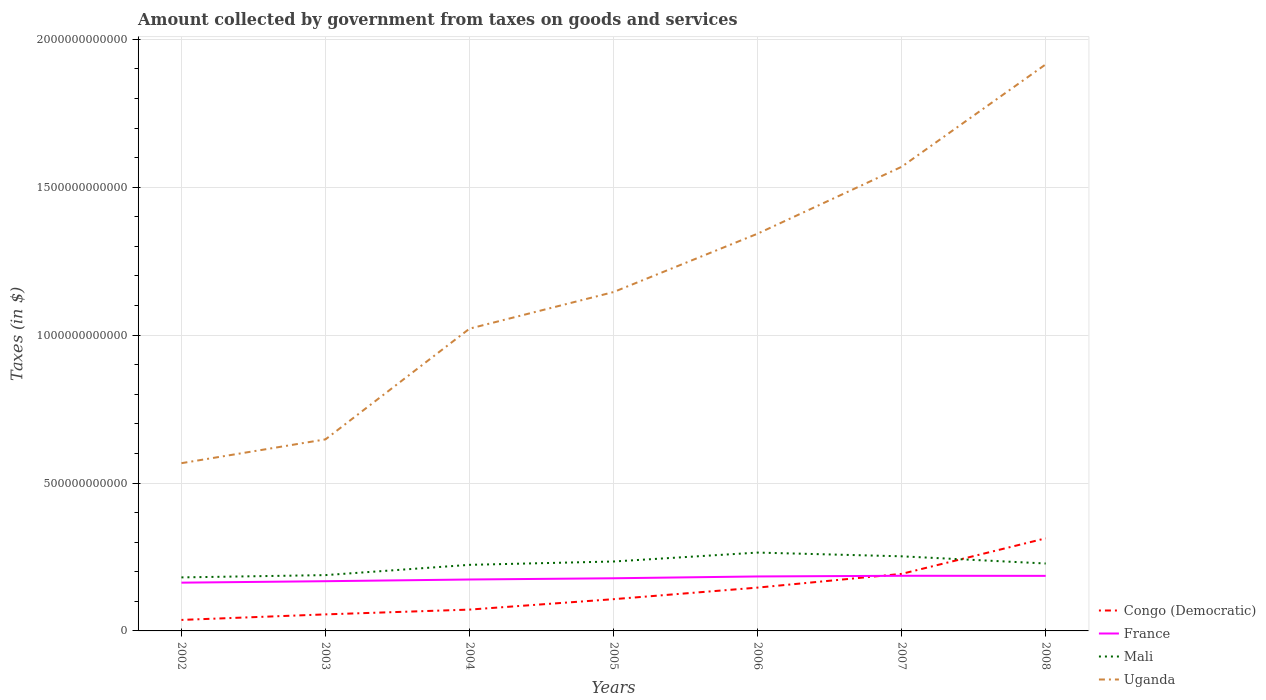Is the number of lines equal to the number of legend labels?
Provide a succinct answer. Yes. Across all years, what is the maximum amount collected by government from taxes on goods and services in Uganda?
Your answer should be very brief. 5.67e+11. What is the total amount collected by government from taxes on goods and services in Congo (Democratic) in the graph?
Your answer should be very brief. -5.14e+1. What is the difference between the highest and the second highest amount collected by government from taxes on goods and services in Congo (Democratic)?
Your answer should be compact. 2.76e+11. What is the difference between the highest and the lowest amount collected by government from taxes on goods and services in Congo (Democratic)?
Keep it short and to the point. 3. How many lines are there?
Provide a short and direct response. 4. How many years are there in the graph?
Your response must be concise. 7. What is the difference between two consecutive major ticks on the Y-axis?
Keep it short and to the point. 5.00e+11. Are the values on the major ticks of Y-axis written in scientific E-notation?
Your answer should be very brief. No. Does the graph contain grids?
Give a very brief answer. Yes. Where does the legend appear in the graph?
Make the answer very short. Bottom right. How many legend labels are there?
Ensure brevity in your answer.  4. What is the title of the graph?
Your answer should be very brief. Amount collected by government from taxes on goods and services. What is the label or title of the X-axis?
Your response must be concise. Years. What is the label or title of the Y-axis?
Your answer should be compact. Taxes (in $). What is the Taxes (in $) of Congo (Democratic) in 2002?
Your answer should be compact. 3.72e+1. What is the Taxes (in $) in France in 2002?
Offer a very short reply. 1.63e+11. What is the Taxes (in $) of Mali in 2002?
Your answer should be compact. 1.81e+11. What is the Taxes (in $) in Uganda in 2002?
Offer a terse response. 5.67e+11. What is the Taxes (in $) of Congo (Democratic) in 2003?
Your answer should be compact. 5.59e+1. What is the Taxes (in $) of France in 2003?
Your answer should be very brief. 1.68e+11. What is the Taxes (in $) of Mali in 2003?
Your answer should be compact. 1.89e+11. What is the Taxes (in $) of Uganda in 2003?
Give a very brief answer. 6.48e+11. What is the Taxes (in $) in Congo (Democratic) in 2004?
Offer a terse response. 7.21e+1. What is the Taxes (in $) in France in 2004?
Provide a short and direct response. 1.74e+11. What is the Taxes (in $) in Mali in 2004?
Your answer should be very brief. 2.23e+11. What is the Taxes (in $) of Uganda in 2004?
Keep it short and to the point. 1.02e+12. What is the Taxes (in $) of Congo (Democratic) in 2005?
Your answer should be compact. 1.07e+11. What is the Taxes (in $) of France in 2005?
Offer a very short reply. 1.78e+11. What is the Taxes (in $) of Mali in 2005?
Your answer should be very brief. 2.35e+11. What is the Taxes (in $) in Uganda in 2005?
Offer a terse response. 1.15e+12. What is the Taxes (in $) in Congo (Democratic) in 2006?
Your response must be concise. 1.46e+11. What is the Taxes (in $) in France in 2006?
Your answer should be very brief. 1.84e+11. What is the Taxes (in $) of Mali in 2006?
Offer a terse response. 2.65e+11. What is the Taxes (in $) of Uganda in 2006?
Provide a short and direct response. 1.34e+12. What is the Taxes (in $) of Congo (Democratic) in 2007?
Offer a very short reply. 1.93e+11. What is the Taxes (in $) of France in 2007?
Offer a very short reply. 1.86e+11. What is the Taxes (in $) in Mali in 2007?
Keep it short and to the point. 2.52e+11. What is the Taxes (in $) in Uganda in 2007?
Provide a succinct answer. 1.57e+12. What is the Taxes (in $) in Congo (Democratic) in 2008?
Offer a very short reply. 3.13e+11. What is the Taxes (in $) of France in 2008?
Give a very brief answer. 1.86e+11. What is the Taxes (in $) of Mali in 2008?
Provide a short and direct response. 2.28e+11. What is the Taxes (in $) in Uganda in 2008?
Provide a short and direct response. 1.92e+12. Across all years, what is the maximum Taxes (in $) in Congo (Democratic)?
Offer a terse response. 3.13e+11. Across all years, what is the maximum Taxes (in $) in France?
Offer a very short reply. 1.86e+11. Across all years, what is the maximum Taxes (in $) of Mali?
Offer a very short reply. 2.65e+11. Across all years, what is the maximum Taxes (in $) in Uganda?
Provide a succinct answer. 1.92e+12. Across all years, what is the minimum Taxes (in $) of Congo (Democratic)?
Your answer should be compact. 3.72e+1. Across all years, what is the minimum Taxes (in $) in France?
Your answer should be very brief. 1.63e+11. Across all years, what is the minimum Taxes (in $) of Mali?
Make the answer very short. 1.81e+11. Across all years, what is the minimum Taxes (in $) of Uganda?
Keep it short and to the point. 5.67e+11. What is the total Taxes (in $) in Congo (Democratic) in the graph?
Your response must be concise. 9.25e+11. What is the total Taxes (in $) of France in the graph?
Give a very brief answer. 1.24e+12. What is the total Taxes (in $) of Mali in the graph?
Your answer should be very brief. 1.57e+12. What is the total Taxes (in $) of Uganda in the graph?
Your answer should be compact. 8.21e+12. What is the difference between the Taxes (in $) in Congo (Democratic) in 2002 and that in 2003?
Your answer should be compact. -1.87e+1. What is the difference between the Taxes (in $) in France in 2002 and that in 2003?
Provide a short and direct response. -4.87e+09. What is the difference between the Taxes (in $) of Mali in 2002 and that in 2003?
Your answer should be compact. -7.72e+09. What is the difference between the Taxes (in $) of Uganda in 2002 and that in 2003?
Make the answer very short. -8.05e+1. What is the difference between the Taxes (in $) in Congo (Democratic) in 2002 and that in 2004?
Your answer should be very brief. -3.49e+1. What is the difference between the Taxes (in $) of France in 2002 and that in 2004?
Your response must be concise. -1.06e+1. What is the difference between the Taxes (in $) of Mali in 2002 and that in 2004?
Make the answer very short. -4.24e+1. What is the difference between the Taxes (in $) of Uganda in 2002 and that in 2004?
Offer a very short reply. -4.55e+11. What is the difference between the Taxes (in $) in Congo (Democratic) in 2002 and that in 2005?
Keep it short and to the point. -7.02e+1. What is the difference between the Taxes (in $) of France in 2002 and that in 2005?
Give a very brief answer. -1.48e+1. What is the difference between the Taxes (in $) in Mali in 2002 and that in 2005?
Your answer should be very brief. -5.37e+1. What is the difference between the Taxes (in $) of Uganda in 2002 and that in 2005?
Keep it short and to the point. -5.78e+11. What is the difference between the Taxes (in $) of Congo (Democratic) in 2002 and that in 2006?
Your answer should be compact. -1.09e+11. What is the difference between the Taxes (in $) of France in 2002 and that in 2006?
Keep it short and to the point. -2.09e+1. What is the difference between the Taxes (in $) in Mali in 2002 and that in 2006?
Keep it short and to the point. -8.39e+1. What is the difference between the Taxes (in $) of Uganda in 2002 and that in 2006?
Make the answer very short. -7.76e+11. What is the difference between the Taxes (in $) of Congo (Democratic) in 2002 and that in 2007?
Provide a short and direct response. -1.56e+11. What is the difference between the Taxes (in $) in France in 2002 and that in 2007?
Ensure brevity in your answer.  -2.32e+1. What is the difference between the Taxes (in $) of Mali in 2002 and that in 2007?
Make the answer very short. -7.13e+1. What is the difference between the Taxes (in $) in Uganda in 2002 and that in 2007?
Offer a very short reply. -1.00e+12. What is the difference between the Taxes (in $) of Congo (Democratic) in 2002 and that in 2008?
Keep it short and to the point. -2.76e+11. What is the difference between the Taxes (in $) in France in 2002 and that in 2008?
Provide a succinct answer. -2.29e+1. What is the difference between the Taxes (in $) of Mali in 2002 and that in 2008?
Offer a very short reply. -4.70e+1. What is the difference between the Taxes (in $) in Uganda in 2002 and that in 2008?
Keep it short and to the point. -1.35e+12. What is the difference between the Taxes (in $) in Congo (Democratic) in 2003 and that in 2004?
Your response must be concise. -1.62e+1. What is the difference between the Taxes (in $) in France in 2003 and that in 2004?
Offer a very short reply. -5.76e+09. What is the difference between the Taxes (in $) in Mali in 2003 and that in 2004?
Your answer should be very brief. -3.47e+1. What is the difference between the Taxes (in $) of Uganda in 2003 and that in 2004?
Your response must be concise. -3.74e+11. What is the difference between the Taxes (in $) of Congo (Democratic) in 2003 and that in 2005?
Your response must be concise. -5.14e+1. What is the difference between the Taxes (in $) in France in 2003 and that in 2005?
Provide a succinct answer. -9.95e+09. What is the difference between the Taxes (in $) of Mali in 2003 and that in 2005?
Offer a terse response. -4.60e+1. What is the difference between the Taxes (in $) of Uganda in 2003 and that in 2005?
Keep it short and to the point. -4.98e+11. What is the difference between the Taxes (in $) in Congo (Democratic) in 2003 and that in 2006?
Your response must be concise. -9.05e+1. What is the difference between the Taxes (in $) of France in 2003 and that in 2006?
Provide a short and direct response. -1.61e+1. What is the difference between the Taxes (in $) of Mali in 2003 and that in 2006?
Keep it short and to the point. -7.62e+1. What is the difference between the Taxes (in $) of Uganda in 2003 and that in 2006?
Provide a succinct answer. -6.95e+11. What is the difference between the Taxes (in $) of Congo (Democratic) in 2003 and that in 2007?
Offer a terse response. -1.37e+11. What is the difference between the Taxes (in $) in France in 2003 and that in 2007?
Provide a succinct answer. -1.84e+1. What is the difference between the Taxes (in $) in Mali in 2003 and that in 2007?
Offer a very short reply. -6.35e+1. What is the difference between the Taxes (in $) of Uganda in 2003 and that in 2007?
Your response must be concise. -9.21e+11. What is the difference between the Taxes (in $) in Congo (Democratic) in 2003 and that in 2008?
Your answer should be very brief. -2.57e+11. What is the difference between the Taxes (in $) in France in 2003 and that in 2008?
Offer a terse response. -1.81e+1. What is the difference between the Taxes (in $) in Mali in 2003 and that in 2008?
Ensure brevity in your answer.  -3.92e+1. What is the difference between the Taxes (in $) in Uganda in 2003 and that in 2008?
Your answer should be compact. -1.27e+12. What is the difference between the Taxes (in $) in Congo (Democratic) in 2004 and that in 2005?
Provide a succinct answer. -3.52e+1. What is the difference between the Taxes (in $) in France in 2004 and that in 2005?
Offer a very short reply. -4.18e+09. What is the difference between the Taxes (in $) of Mali in 2004 and that in 2005?
Your answer should be compact. -1.13e+1. What is the difference between the Taxes (in $) of Uganda in 2004 and that in 2005?
Your response must be concise. -1.24e+11. What is the difference between the Taxes (in $) in Congo (Democratic) in 2004 and that in 2006?
Give a very brief answer. -7.43e+1. What is the difference between the Taxes (in $) of France in 2004 and that in 2006?
Your response must be concise. -1.03e+1. What is the difference between the Taxes (in $) in Mali in 2004 and that in 2006?
Make the answer very short. -4.14e+1. What is the difference between the Taxes (in $) of Uganda in 2004 and that in 2006?
Give a very brief answer. -3.21e+11. What is the difference between the Taxes (in $) in Congo (Democratic) in 2004 and that in 2007?
Your response must be concise. -1.21e+11. What is the difference between the Taxes (in $) in France in 2004 and that in 2007?
Your answer should be compact. -1.26e+1. What is the difference between the Taxes (in $) of Mali in 2004 and that in 2007?
Offer a very short reply. -2.88e+1. What is the difference between the Taxes (in $) of Uganda in 2004 and that in 2007?
Your response must be concise. -5.47e+11. What is the difference between the Taxes (in $) in Congo (Democratic) in 2004 and that in 2008?
Give a very brief answer. -2.41e+11. What is the difference between the Taxes (in $) of France in 2004 and that in 2008?
Make the answer very short. -1.23e+1. What is the difference between the Taxes (in $) of Mali in 2004 and that in 2008?
Ensure brevity in your answer.  -4.52e+09. What is the difference between the Taxes (in $) in Uganda in 2004 and that in 2008?
Your response must be concise. -8.93e+11. What is the difference between the Taxes (in $) of Congo (Democratic) in 2005 and that in 2006?
Ensure brevity in your answer.  -3.91e+1. What is the difference between the Taxes (in $) of France in 2005 and that in 2006?
Ensure brevity in your answer.  -6.13e+09. What is the difference between the Taxes (in $) in Mali in 2005 and that in 2006?
Your answer should be compact. -3.02e+1. What is the difference between the Taxes (in $) in Uganda in 2005 and that in 2006?
Offer a terse response. -1.97e+11. What is the difference between the Taxes (in $) of Congo (Democratic) in 2005 and that in 2007?
Provide a succinct answer. -8.55e+1. What is the difference between the Taxes (in $) in France in 2005 and that in 2007?
Provide a succinct answer. -8.41e+09. What is the difference between the Taxes (in $) of Mali in 2005 and that in 2007?
Offer a terse response. -1.75e+1. What is the difference between the Taxes (in $) of Uganda in 2005 and that in 2007?
Offer a very short reply. -4.23e+11. What is the difference between the Taxes (in $) in Congo (Democratic) in 2005 and that in 2008?
Make the answer very short. -2.06e+11. What is the difference between the Taxes (in $) in France in 2005 and that in 2008?
Offer a terse response. -8.12e+09. What is the difference between the Taxes (in $) in Mali in 2005 and that in 2008?
Provide a short and direct response. 6.78e+09. What is the difference between the Taxes (in $) in Uganda in 2005 and that in 2008?
Ensure brevity in your answer.  -7.70e+11. What is the difference between the Taxes (in $) of Congo (Democratic) in 2006 and that in 2007?
Ensure brevity in your answer.  -4.64e+1. What is the difference between the Taxes (in $) of France in 2006 and that in 2007?
Ensure brevity in your answer.  -2.28e+09. What is the difference between the Taxes (in $) in Mali in 2006 and that in 2007?
Provide a short and direct response. 1.26e+1. What is the difference between the Taxes (in $) of Uganda in 2006 and that in 2007?
Provide a short and direct response. -2.26e+11. What is the difference between the Taxes (in $) of Congo (Democratic) in 2006 and that in 2008?
Offer a terse response. -1.67e+11. What is the difference between the Taxes (in $) in France in 2006 and that in 2008?
Your response must be concise. -1.99e+09. What is the difference between the Taxes (in $) in Mali in 2006 and that in 2008?
Provide a succinct answer. 3.69e+1. What is the difference between the Taxes (in $) of Uganda in 2006 and that in 2008?
Your answer should be very brief. -5.72e+11. What is the difference between the Taxes (in $) of Congo (Democratic) in 2007 and that in 2008?
Your response must be concise. -1.20e+11. What is the difference between the Taxes (in $) of France in 2007 and that in 2008?
Ensure brevity in your answer.  2.90e+08. What is the difference between the Taxes (in $) of Mali in 2007 and that in 2008?
Ensure brevity in your answer.  2.43e+1. What is the difference between the Taxes (in $) of Uganda in 2007 and that in 2008?
Your answer should be compact. -3.46e+11. What is the difference between the Taxes (in $) of Congo (Democratic) in 2002 and the Taxes (in $) of France in 2003?
Make the answer very short. -1.31e+11. What is the difference between the Taxes (in $) in Congo (Democratic) in 2002 and the Taxes (in $) in Mali in 2003?
Offer a very short reply. -1.51e+11. What is the difference between the Taxes (in $) in Congo (Democratic) in 2002 and the Taxes (in $) in Uganda in 2003?
Provide a short and direct response. -6.10e+11. What is the difference between the Taxes (in $) in France in 2002 and the Taxes (in $) in Mali in 2003?
Your answer should be very brief. -2.55e+1. What is the difference between the Taxes (in $) of France in 2002 and the Taxes (in $) of Uganda in 2003?
Offer a very short reply. -4.84e+11. What is the difference between the Taxes (in $) in Mali in 2002 and the Taxes (in $) in Uganda in 2003?
Offer a very short reply. -4.67e+11. What is the difference between the Taxes (in $) in Congo (Democratic) in 2002 and the Taxes (in $) in France in 2004?
Make the answer very short. -1.37e+11. What is the difference between the Taxes (in $) in Congo (Democratic) in 2002 and the Taxes (in $) in Mali in 2004?
Keep it short and to the point. -1.86e+11. What is the difference between the Taxes (in $) in Congo (Democratic) in 2002 and the Taxes (in $) in Uganda in 2004?
Your answer should be very brief. -9.85e+11. What is the difference between the Taxes (in $) in France in 2002 and the Taxes (in $) in Mali in 2004?
Give a very brief answer. -6.02e+1. What is the difference between the Taxes (in $) of France in 2002 and the Taxes (in $) of Uganda in 2004?
Your response must be concise. -8.59e+11. What is the difference between the Taxes (in $) of Mali in 2002 and the Taxes (in $) of Uganda in 2004?
Your response must be concise. -8.41e+11. What is the difference between the Taxes (in $) in Congo (Democratic) in 2002 and the Taxes (in $) in France in 2005?
Your response must be concise. -1.41e+11. What is the difference between the Taxes (in $) in Congo (Democratic) in 2002 and the Taxes (in $) in Mali in 2005?
Offer a terse response. -1.98e+11. What is the difference between the Taxes (in $) of Congo (Democratic) in 2002 and the Taxes (in $) of Uganda in 2005?
Provide a short and direct response. -1.11e+12. What is the difference between the Taxes (in $) in France in 2002 and the Taxes (in $) in Mali in 2005?
Provide a short and direct response. -7.15e+1. What is the difference between the Taxes (in $) of France in 2002 and the Taxes (in $) of Uganda in 2005?
Your answer should be compact. -9.82e+11. What is the difference between the Taxes (in $) in Mali in 2002 and the Taxes (in $) in Uganda in 2005?
Your response must be concise. -9.65e+11. What is the difference between the Taxes (in $) in Congo (Democratic) in 2002 and the Taxes (in $) in France in 2006?
Provide a short and direct response. -1.47e+11. What is the difference between the Taxes (in $) of Congo (Democratic) in 2002 and the Taxes (in $) of Mali in 2006?
Your answer should be compact. -2.28e+11. What is the difference between the Taxes (in $) in Congo (Democratic) in 2002 and the Taxes (in $) in Uganda in 2006?
Keep it short and to the point. -1.31e+12. What is the difference between the Taxes (in $) in France in 2002 and the Taxes (in $) in Mali in 2006?
Your answer should be compact. -1.02e+11. What is the difference between the Taxes (in $) of France in 2002 and the Taxes (in $) of Uganda in 2006?
Make the answer very short. -1.18e+12. What is the difference between the Taxes (in $) in Mali in 2002 and the Taxes (in $) in Uganda in 2006?
Ensure brevity in your answer.  -1.16e+12. What is the difference between the Taxes (in $) of Congo (Democratic) in 2002 and the Taxes (in $) of France in 2007?
Your response must be concise. -1.49e+11. What is the difference between the Taxes (in $) of Congo (Democratic) in 2002 and the Taxes (in $) of Mali in 2007?
Your answer should be compact. -2.15e+11. What is the difference between the Taxes (in $) of Congo (Democratic) in 2002 and the Taxes (in $) of Uganda in 2007?
Provide a short and direct response. -1.53e+12. What is the difference between the Taxes (in $) of France in 2002 and the Taxes (in $) of Mali in 2007?
Provide a short and direct response. -8.90e+1. What is the difference between the Taxes (in $) of France in 2002 and the Taxes (in $) of Uganda in 2007?
Your answer should be very brief. -1.41e+12. What is the difference between the Taxes (in $) of Mali in 2002 and the Taxes (in $) of Uganda in 2007?
Ensure brevity in your answer.  -1.39e+12. What is the difference between the Taxes (in $) in Congo (Democratic) in 2002 and the Taxes (in $) in France in 2008?
Make the answer very short. -1.49e+11. What is the difference between the Taxes (in $) in Congo (Democratic) in 2002 and the Taxes (in $) in Mali in 2008?
Offer a very short reply. -1.91e+11. What is the difference between the Taxes (in $) in Congo (Democratic) in 2002 and the Taxes (in $) in Uganda in 2008?
Your answer should be very brief. -1.88e+12. What is the difference between the Taxes (in $) in France in 2002 and the Taxes (in $) in Mali in 2008?
Give a very brief answer. -6.47e+1. What is the difference between the Taxes (in $) in France in 2002 and the Taxes (in $) in Uganda in 2008?
Your answer should be very brief. -1.75e+12. What is the difference between the Taxes (in $) of Mali in 2002 and the Taxes (in $) of Uganda in 2008?
Provide a short and direct response. -1.73e+12. What is the difference between the Taxes (in $) in Congo (Democratic) in 2003 and the Taxes (in $) in France in 2004?
Provide a short and direct response. -1.18e+11. What is the difference between the Taxes (in $) of Congo (Democratic) in 2003 and the Taxes (in $) of Mali in 2004?
Ensure brevity in your answer.  -1.67e+11. What is the difference between the Taxes (in $) of Congo (Democratic) in 2003 and the Taxes (in $) of Uganda in 2004?
Provide a succinct answer. -9.66e+11. What is the difference between the Taxes (in $) of France in 2003 and the Taxes (in $) of Mali in 2004?
Your answer should be compact. -5.53e+1. What is the difference between the Taxes (in $) in France in 2003 and the Taxes (in $) in Uganda in 2004?
Provide a succinct answer. -8.54e+11. What is the difference between the Taxes (in $) in Mali in 2003 and the Taxes (in $) in Uganda in 2004?
Offer a very short reply. -8.33e+11. What is the difference between the Taxes (in $) in Congo (Democratic) in 2003 and the Taxes (in $) in France in 2005?
Keep it short and to the point. -1.22e+11. What is the difference between the Taxes (in $) of Congo (Democratic) in 2003 and the Taxes (in $) of Mali in 2005?
Offer a terse response. -1.79e+11. What is the difference between the Taxes (in $) in Congo (Democratic) in 2003 and the Taxes (in $) in Uganda in 2005?
Your answer should be compact. -1.09e+12. What is the difference between the Taxes (in $) in France in 2003 and the Taxes (in $) in Mali in 2005?
Keep it short and to the point. -6.66e+1. What is the difference between the Taxes (in $) in France in 2003 and the Taxes (in $) in Uganda in 2005?
Keep it short and to the point. -9.77e+11. What is the difference between the Taxes (in $) of Mali in 2003 and the Taxes (in $) of Uganda in 2005?
Provide a short and direct response. -9.57e+11. What is the difference between the Taxes (in $) in Congo (Democratic) in 2003 and the Taxes (in $) in France in 2006?
Your response must be concise. -1.28e+11. What is the difference between the Taxes (in $) of Congo (Democratic) in 2003 and the Taxes (in $) of Mali in 2006?
Your response must be concise. -2.09e+11. What is the difference between the Taxes (in $) in Congo (Democratic) in 2003 and the Taxes (in $) in Uganda in 2006?
Your answer should be compact. -1.29e+12. What is the difference between the Taxes (in $) of France in 2003 and the Taxes (in $) of Mali in 2006?
Your answer should be compact. -9.68e+1. What is the difference between the Taxes (in $) of France in 2003 and the Taxes (in $) of Uganda in 2006?
Keep it short and to the point. -1.17e+12. What is the difference between the Taxes (in $) of Mali in 2003 and the Taxes (in $) of Uganda in 2006?
Your answer should be compact. -1.15e+12. What is the difference between the Taxes (in $) of Congo (Democratic) in 2003 and the Taxes (in $) of France in 2007?
Offer a terse response. -1.31e+11. What is the difference between the Taxes (in $) of Congo (Democratic) in 2003 and the Taxes (in $) of Mali in 2007?
Ensure brevity in your answer.  -1.96e+11. What is the difference between the Taxes (in $) of Congo (Democratic) in 2003 and the Taxes (in $) of Uganda in 2007?
Provide a short and direct response. -1.51e+12. What is the difference between the Taxes (in $) in France in 2003 and the Taxes (in $) in Mali in 2007?
Your answer should be very brief. -8.42e+1. What is the difference between the Taxes (in $) in France in 2003 and the Taxes (in $) in Uganda in 2007?
Provide a succinct answer. -1.40e+12. What is the difference between the Taxes (in $) in Mali in 2003 and the Taxes (in $) in Uganda in 2007?
Your answer should be compact. -1.38e+12. What is the difference between the Taxes (in $) of Congo (Democratic) in 2003 and the Taxes (in $) of France in 2008?
Provide a short and direct response. -1.30e+11. What is the difference between the Taxes (in $) of Congo (Democratic) in 2003 and the Taxes (in $) of Mali in 2008?
Give a very brief answer. -1.72e+11. What is the difference between the Taxes (in $) of Congo (Democratic) in 2003 and the Taxes (in $) of Uganda in 2008?
Provide a succinct answer. -1.86e+12. What is the difference between the Taxes (in $) of France in 2003 and the Taxes (in $) of Mali in 2008?
Your answer should be very brief. -5.98e+1. What is the difference between the Taxes (in $) in France in 2003 and the Taxes (in $) in Uganda in 2008?
Provide a short and direct response. -1.75e+12. What is the difference between the Taxes (in $) of Mali in 2003 and the Taxes (in $) of Uganda in 2008?
Offer a terse response. -1.73e+12. What is the difference between the Taxes (in $) of Congo (Democratic) in 2004 and the Taxes (in $) of France in 2005?
Offer a very short reply. -1.06e+11. What is the difference between the Taxes (in $) in Congo (Democratic) in 2004 and the Taxes (in $) in Mali in 2005?
Give a very brief answer. -1.63e+11. What is the difference between the Taxes (in $) in Congo (Democratic) in 2004 and the Taxes (in $) in Uganda in 2005?
Offer a terse response. -1.07e+12. What is the difference between the Taxes (in $) in France in 2004 and the Taxes (in $) in Mali in 2005?
Your response must be concise. -6.09e+1. What is the difference between the Taxes (in $) of France in 2004 and the Taxes (in $) of Uganda in 2005?
Keep it short and to the point. -9.72e+11. What is the difference between the Taxes (in $) in Mali in 2004 and the Taxes (in $) in Uganda in 2005?
Your response must be concise. -9.22e+11. What is the difference between the Taxes (in $) of Congo (Democratic) in 2004 and the Taxes (in $) of France in 2006?
Your answer should be compact. -1.12e+11. What is the difference between the Taxes (in $) in Congo (Democratic) in 2004 and the Taxes (in $) in Mali in 2006?
Give a very brief answer. -1.93e+11. What is the difference between the Taxes (in $) of Congo (Democratic) in 2004 and the Taxes (in $) of Uganda in 2006?
Your response must be concise. -1.27e+12. What is the difference between the Taxes (in $) of France in 2004 and the Taxes (in $) of Mali in 2006?
Provide a succinct answer. -9.10e+1. What is the difference between the Taxes (in $) in France in 2004 and the Taxes (in $) in Uganda in 2006?
Keep it short and to the point. -1.17e+12. What is the difference between the Taxes (in $) of Mali in 2004 and the Taxes (in $) of Uganda in 2006?
Your answer should be compact. -1.12e+12. What is the difference between the Taxes (in $) of Congo (Democratic) in 2004 and the Taxes (in $) of France in 2007?
Your response must be concise. -1.14e+11. What is the difference between the Taxes (in $) in Congo (Democratic) in 2004 and the Taxes (in $) in Mali in 2007?
Ensure brevity in your answer.  -1.80e+11. What is the difference between the Taxes (in $) of Congo (Democratic) in 2004 and the Taxes (in $) of Uganda in 2007?
Offer a terse response. -1.50e+12. What is the difference between the Taxes (in $) of France in 2004 and the Taxes (in $) of Mali in 2007?
Give a very brief answer. -7.84e+1. What is the difference between the Taxes (in $) of France in 2004 and the Taxes (in $) of Uganda in 2007?
Provide a succinct answer. -1.40e+12. What is the difference between the Taxes (in $) in Mali in 2004 and the Taxes (in $) in Uganda in 2007?
Keep it short and to the point. -1.35e+12. What is the difference between the Taxes (in $) of Congo (Democratic) in 2004 and the Taxes (in $) of France in 2008?
Make the answer very short. -1.14e+11. What is the difference between the Taxes (in $) of Congo (Democratic) in 2004 and the Taxes (in $) of Mali in 2008?
Offer a very short reply. -1.56e+11. What is the difference between the Taxes (in $) in Congo (Democratic) in 2004 and the Taxes (in $) in Uganda in 2008?
Provide a short and direct response. -1.84e+12. What is the difference between the Taxes (in $) in France in 2004 and the Taxes (in $) in Mali in 2008?
Provide a short and direct response. -5.41e+1. What is the difference between the Taxes (in $) in France in 2004 and the Taxes (in $) in Uganda in 2008?
Your response must be concise. -1.74e+12. What is the difference between the Taxes (in $) of Mali in 2004 and the Taxes (in $) of Uganda in 2008?
Provide a succinct answer. -1.69e+12. What is the difference between the Taxes (in $) in Congo (Democratic) in 2005 and the Taxes (in $) in France in 2006?
Your response must be concise. -7.68e+1. What is the difference between the Taxes (in $) of Congo (Democratic) in 2005 and the Taxes (in $) of Mali in 2006?
Keep it short and to the point. -1.58e+11. What is the difference between the Taxes (in $) in Congo (Democratic) in 2005 and the Taxes (in $) in Uganda in 2006?
Offer a very short reply. -1.24e+12. What is the difference between the Taxes (in $) of France in 2005 and the Taxes (in $) of Mali in 2006?
Offer a very short reply. -8.68e+1. What is the difference between the Taxes (in $) of France in 2005 and the Taxes (in $) of Uganda in 2006?
Provide a succinct answer. -1.16e+12. What is the difference between the Taxes (in $) in Mali in 2005 and the Taxes (in $) in Uganda in 2006?
Your answer should be very brief. -1.11e+12. What is the difference between the Taxes (in $) of Congo (Democratic) in 2005 and the Taxes (in $) of France in 2007?
Provide a succinct answer. -7.91e+1. What is the difference between the Taxes (in $) in Congo (Democratic) in 2005 and the Taxes (in $) in Mali in 2007?
Your answer should be very brief. -1.45e+11. What is the difference between the Taxes (in $) in Congo (Democratic) in 2005 and the Taxes (in $) in Uganda in 2007?
Make the answer very short. -1.46e+12. What is the difference between the Taxes (in $) of France in 2005 and the Taxes (in $) of Mali in 2007?
Offer a very short reply. -7.42e+1. What is the difference between the Taxes (in $) in France in 2005 and the Taxes (in $) in Uganda in 2007?
Offer a terse response. -1.39e+12. What is the difference between the Taxes (in $) of Mali in 2005 and the Taxes (in $) of Uganda in 2007?
Your response must be concise. -1.33e+12. What is the difference between the Taxes (in $) in Congo (Democratic) in 2005 and the Taxes (in $) in France in 2008?
Ensure brevity in your answer.  -7.88e+1. What is the difference between the Taxes (in $) in Congo (Democratic) in 2005 and the Taxes (in $) in Mali in 2008?
Ensure brevity in your answer.  -1.21e+11. What is the difference between the Taxes (in $) in Congo (Democratic) in 2005 and the Taxes (in $) in Uganda in 2008?
Give a very brief answer. -1.81e+12. What is the difference between the Taxes (in $) in France in 2005 and the Taxes (in $) in Mali in 2008?
Keep it short and to the point. -4.99e+1. What is the difference between the Taxes (in $) of France in 2005 and the Taxes (in $) of Uganda in 2008?
Provide a short and direct response. -1.74e+12. What is the difference between the Taxes (in $) in Mali in 2005 and the Taxes (in $) in Uganda in 2008?
Your answer should be compact. -1.68e+12. What is the difference between the Taxes (in $) of Congo (Democratic) in 2006 and the Taxes (in $) of France in 2007?
Make the answer very short. -4.00e+1. What is the difference between the Taxes (in $) in Congo (Democratic) in 2006 and the Taxes (in $) in Mali in 2007?
Ensure brevity in your answer.  -1.06e+11. What is the difference between the Taxes (in $) of Congo (Democratic) in 2006 and the Taxes (in $) of Uganda in 2007?
Offer a terse response. -1.42e+12. What is the difference between the Taxes (in $) of France in 2006 and the Taxes (in $) of Mali in 2007?
Your answer should be very brief. -6.81e+1. What is the difference between the Taxes (in $) of France in 2006 and the Taxes (in $) of Uganda in 2007?
Make the answer very short. -1.38e+12. What is the difference between the Taxes (in $) of Mali in 2006 and the Taxes (in $) of Uganda in 2007?
Provide a short and direct response. -1.30e+12. What is the difference between the Taxes (in $) of Congo (Democratic) in 2006 and the Taxes (in $) of France in 2008?
Offer a very short reply. -3.97e+1. What is the difference between the Taxes (in $) in Congo (Democratic) in 2006 and the Taxes (in $) in Mali in 2008?
Give a very brief answer. -8.15e+1. What is the difference between the Taxes (in $) in Congo (Democratic) in 2006 and the Taxes (in $) in Uganda in 2008?
Make the answer very short. -1.77e+12. What is the difference between the Taxes (in $) in France in 2006 and the Taxes (in $) in Mali in 2008?
Make the answer very short. -4.38e+1. What is the difference between the Taxes (in $) in France in 2006 and the Taxes (in $) in Uganda in 2008?
Provide a short and direct response. -1.73e+12. What is the difference between the Taxes (in $) of Mali in 2006 and the Taxes (in $) of Uganda in 2008?
Provide a succinct answer. -1.65e+12. What is the difference between the Taxes (in $) in Congo (Democratic) in 2007 and the Taxes (in $) in France in 2008?
Your answer should be very brief. 6.72e+09. What is the difference between the Taxes (in $) of Congo (Democratic) in 2007 and the Taxes (in $) of Mali in 2008?
Provide a short and direct response. -3.51e+1. What is the difference between the Taxes (in $) in Congo (Democratic) in 2007 and the Taxes (in $) in Uganda in 2008?
Offer a very short reply. -1.72e+12. What is the difference between the Taxes (in $) in France in 2007 and the Taxes (in $) in Mali in 2008?
Offer a terse response. -4.15e+1. What is the difference between the Taxes (in $) in France in 2007 and the Taxes (in $) in Uganda in 2008?
Offer a very short reply. -1.73e+12. What is the difference between the Taxes (in $) of Mali in 2007 and the Taxes (in $) of Uganda in 2008?
Keep it short and to the point. -1.66e+12. What is the average Taxes (in $) of Congo (Democratic) per year?
Your answer should be compact. 1.32e+11. What is the average Taxes (in $) of France per year?
Make the answer very short. 1.77e+11. What is the average Taxes (in $) of Mali per year?
Make the answer very short. 2.25e+11. What is the average Taxes (in $) of Uganda per year?
Your answer should be very brief. 1.17e+12. In the year 2002, what is the difference between the Taxes (in $) in Congo (Democratic) and Taxes (in $) in France?
Provide a succinct answer. -1.26e+11. In the year 2002, what is the difference between the Taxes (in $) in Congo (Democratic) and Taxes (in $) in Mali?
Ensure brevity in your answer.  -1.44e+11. In the year 2002, what is the difference between the Taxes (in $) of Congo (Democratic) and Taxes (in $) of Uganda?
Offer a terse response. -5.30e+11. In the year 2002, what is the difference between the Taxes (in $) of France and Taxes (in $) of Mali?
Your answer should be compact. -1.78e+1. In the year 2002, what is the difference between the Taxes (in $) in France and Taxes (in $) in Uganda?
Provide a succinct answer. -4.04e+11. In the year 2002, what is the difference between the Taxes (in $) in Mali and Taxes (in $) in Uganda?
Your answer should be very brief. -3.86e+11. In the year 2003, what is the difference between the Taxes (in $) of Congo (Democratic) and Taxes (in $) of France?
Your response must be concise. -1.12e+11. In the year 2003, what is the difference between the Taxes (in $) of Congo (Democratic) and Taxes (in $) of Mali?
Ensure brevity in your answer.  -1.33e+11. In the year 2003, what is the difference between the Taxes (in $) in Congo (Democratic) and Taxes (in $) in Uganda?
Give a very brief answer. -5.92e+11. In the year 2003, what is the difference between the Taxes (in $) in France and Taxes (in $) in Mali?
Offer a very short reply. -2.06e+1. In the year 2003, what is the difference between the Taxes (in $) in France and Taxes (in $) in Uganda?
Your answer should be compact. -4.79e+11. In the year 2003, what is the difference between the Taxes (in $) of Mali and Taxes (in $) of Uganda?
Provide a succinct answer. -4.59e+11. In the year 2004, what is the difference between the Taxes (in $) of Congo (Democratic) and Taxes (in $) of France?
Provide a succinct answer. -1.02e+11. In the year 2004, what is the difference between the Taxes (in $) in Congo (Democratic) and Taxes (in $) in Mali?
Keep it short and to the point. -1.51e+11. In the year 2004, what is the difference between the Taxes (in $) in Congo (Democratic) and Taxes (in $) in Uganda?
Make the answer very short. -9.50e+11. In the year 2004, what is the difference between the Taxes (in $) in France and Taxes (in $) in Mali?
Make the answer very short. -4.96e+1. In the year 2004, what is the difference between the Taxes (in $) in France and Taxes (in $) in Uganda?
Make the answer very short. -8.48e+11. In the year 2004, what is the difference between the Taxes (in $) of Mali and Taxes (in $) of Uganda?
Your answer should be very brief. -7.98e+11. In the year 2005, what is the difference between the Taxes (in $) in Congo (Democratic) and Taxes (in $) in France?
Provide a short and direct response. -7.07e+1. In the year 2005, what is the difference between the Taxes (in $) of Congo (Democratic) and Taxes (in $) of Mali?
Make the answer very short. -1.27e+11. In the year 2005, what is the difference between the Taxes (in $) in Congo (Democratic) and Taxes (in $) in Uganda?
Make the answer very short. -1.04e+12. In the year 2005, what is the difference between the Taxes (in $) of France and Taxes (in $) of Mali?
Your answer should be very brief. -5.67e+1. In the year 2005, what is the difference between the Taxes (in $) in France and Taxes (in $) in Uganda?
Keep it short and to the point. -9.68e+11. In the year 2005, what is the difference between the Taxes (in $) of Mali and Taxes (in $) of Uganda?
Your answer should be very brief. -9.11e+11. In the year 2006, what is the difference between the Taxes (in $) of Congo (Democratic) and Taxes (in $) of France?
Keep it short and to the point. -3.77e+1. In the year 2006, what is the difference between the Taxes (in $) in Congo (Democratic) and Taxes (in $) in Mali?
Your answer should be compact. -1.18e+11. In the year 2006, what is the difference between the Taxes (in $) in Congo (Democratic) and Taxes (in $) in Uganda?
Offer a terse response. -1.20e+12. In the year 2006, what is the difference between the Taxes (in $) in France and Taxes (in $) in Mali?
Give a very brief answer. -8.07e+1. In the year 2006, what is the difference between the Taxes (in $) of France and Taxes (in $) of Uganda?
Provide a short and direct response. -1.16e+12. In the year 2006, what is the difference between the Taxes (in $) of Mali and Taxes (in $) of Uganda?
Your answer should be compact. -1.08e+12. In the year 2007, what is the difference between the Taxes (in $) of Congo (Democratic) and Taxes (in $) of France?
Your answer should be very brief. 6.43e+09. In the year 2007, what is the difference between the Taxes (in $) in Congo (Democratic) and Taxes (in $) in Mali?
Keep it short and to the point. -5.94e+1. In the year 2007, what is the difference between the Taxes (in $) of Congo (Democratic) and Taxes (in $) of Uganda?
Offer a terse response. -1.38e+12. In the year 2007, what is the difference between the Taxes (in $) in France and Taxes (in $) in Mali?
Give a very brief answer. -6.58e+1. In the year 2007, what is the difference between the Taxes (in $) in France and Taxes (in $) in Uganda?
Provide a succinct answer. -1.38e+12. In the year 2007, what is the difference between the Taxes (in $) of Mali and Taxes (in $) of Uganda?
Your answer should be very brief. -1.32e+12. In the year 2008, what is the difference between the Taxes (in $) of Congo (Democratic) and Taxes (in $) of France?
Your response must be concise. 1.27e+11. In the year 2008, what is the difference between the Taxes (in $) in Congo (Democratic) and Taxes (in $) in Mali?
Offer a terse response. 8.51e+1. In the year 2008, what is the difference between the Taxes (in $) in Congo (Democratic) and Taxes (in $) in Uganda?
Ensure brevity in your answer.  -1.60e+12. In the year 2008, what is the difference between the Taxes (in $) of France and Taxes (in $) of Mali?
Your response must be concise. -4.18e+1. In the year 2008, what is the difference between the Taxes (in $) in France and Taxes (in $) in Uganda?
Your response must be concise. -1.73e+12. In the year 2008, what is the difference between the Taxes (in $) in Mali and Taxes (in $) in Uganda?
Keep it short and to the point. -1.69e+12. What is the ratio of the Taxes (in $) of Congo (Democratic) in 2002 to that in 2003?
Ensure brevity in your answer.  0.67. What is the ratio of the Taxes (in $) in Mali in 2002 to that in 2003?
Keep it short and to the point. 0.96. What is the ratio of the Taxes (in $) in Uganda in 2002 to that in 2003?
Keep it short and to the point. 0.88. What is the ratio of the Taxes (in $) of Congo (Democratic) in 2002 to that in 2004?
Make the answer very short. 0.52. What is the ratio of the Taxes (in $) of France in 2002 to that in 2004?
Provide a short and direct response. 0.94. What is the ratio of the Taxes (in $) of Mali in 2002 to that in 2004?
Your answer should be compact. 0.81. What is the ratio of the Taxes (in $) in Uganda in 2002 to that in 2004?
Provide a short and direct response. 0.55. What is the ratio of the Taxes (in $) in Congo (Democratic) in 2002 to that in 2005?
Provide a short and direct response. 0.35. What is the ratio of the Taxes (in $) of France in 2002 to that in 2005?
Offer a terse response. 0.92. What is the ratio of the Taxes (in $) of Mali in 2002 to that in 2005?
Provide a succinct answer. 0.77. What is the ratio of the Taxes (in $) of Uganda in 2002 to that in 2005?
Ensure brevity in your answer.  0.49. What is the ratio of the Taxes (in $) of Congo (Democratic) in 2002 to that in 2006?
Provide a succinct answer. 0.25. What is the ratio of the Taxes (in $) in France in 2002 to that in 2006?
Provide a short and direct response. 0.89. What is the ratio of the Taxes (in $) of Mali in 2002 to that in 2006?
Ensure brevity in your answer.  0.68. What is the ratio of the Taxes (in $) in Uganda in 2002 to that in 2006?
Keep it short and to the point. 0.42. What is the ratio of the Taxes (in $) of Congo (Democratic) in 2002 to that in 2007?
Your response must be concise. 0.19. What is the ratio of the Taxes (in $) of France in 2002 to that in 2007?
Give a very brief answer. 0.88. What is the ratio of the Taxes (in $) of Mali in 2002 to that in 2007?
Your answer should be very brief. 0.72. What is the ratio of the Taxes (in $) of Uganda in 2002 to that in 2007?
Keep it short and to the point. 0.36. What is the ratio of the Taxes (in $) in Congo (Democratic) in 2002 to that in 2008?
Ensure brevity in your answer.  0.12. What is the ratio of the Taxes (in $) in France in 2002 to that in 2008?
Your answer should be very brief. 0.88. What is the ratio of the Taxes (in $) in Mali in 2002 to that in 2008?
Your response must be concise. 0.79. What is the ratio of the Taxes (in $) in Uganda in 2002 to that in 2008?
Your response must be concise. 0.3. What is the ratio of the Taxes (in $) in Congo (Democratic) in 2003 to that in 2004?
Your answer should be compact. 0.78. What is the ratio of the Taxes (in $) in France in 2003 to that in 2004?
Give a very brief answer. 0.97. What is the ratio of the Taxes (in $) of Mali in 2003 to that in 2004?
Your answer should be very brief. 0.84. What is the ratio of the Taxes (in $) in Uganda in 2003 to that in 2004?
Offer a terse response. 0.63. What is the ratio of the Taxes (in $) of Congo (Democratic) in 2003 to that in 2005?
Offer a very short reply. 0.52. What is the ratio of the Taxes (in $) of France in 2003 to that in 2005?
Offer a terse response. 0.94. What is the ratio of the Taxes (in $) in Mali in 2003 to that in 2005?
Your response must be concise. 0.8. What is the ratio of the Taxes (in $) of Uganda in 2003 to that in 2005?
Offer a very short reply. 0.57. What is the ratio of the Taxes (in $) in Congo (Democratic) in 2003 to that in 2006?
Offer a very short reply. 0.38. What is the ratio of the Taxes (in $) of France in 2003 to that in 2006?
Give a very brief answer. 0.91. What is the ratio of the Taxes (in $) of Mali in 2003 to that in 2006?
Give a very brief answer. 0.71. What is the ratio of the Taxes (in $) in Uganda in 2003 to that in 2006?
Provide a short and direct response. 0.48. What is the ratio of the Taxes (in $) of Congo (Democratic) in 2003 to that in 2007?
Give a very brief answer. 0.29. What is the ratio of the Taxes (in $) in France in 2003 to that in 2007?
Ensure brevity in your answer.  0.9. What is the ratio of the Taxes (in $) in Mali in 2003 to that in 2007?
Offer a very short reply. 0.75. What is the ratio of the Taxes (in $) of Uganda in 2003 to that in 2007?
Give a very brief answer. 0.41. What is the ratio of the Taxes (in $) in Congo (Democratic) in 2003 to that in 2008?
Ensure brevity in your answer.  0.18. What is the ratio of the Taxes (in $) of France in 2003 to that in 2008?
Your answer should be very brief. 0.9. What is the ratio of the Taxes (in $) of Mali in 2003 to that in 2008?
Provide a short and direct response. 0.83. What is the ratio of the Taxes (in $) in Uganda in 2003 to that in 2008?
Your answer should be compact. 0.34. What is the ratio of the Taxes (in $) in Congo (Democratic) in 2004 to that in 2005?
Make the answer very short. 0.67. What is the ratio of the Taxes (in $) of France in 2004 to that in 2005?
Provide a succinct answer. 0.98. What is the ratio of the Taxes (in $) of Mali in 2004 to that in 2005?
Your response must be concise. 0.95. What is the ratio of the Taxes (in $) in Uganda in 2004 to that in 2005?
Provide a short and direct response. 0.89. What is the ratio of the Taxes (in $) of Congo (Democratic) in 2004 to that in 2006?
Your response must be concise. 0.49. What is the ratio of the Taxes (in $) in France in 2004 to that in 2006?
Provide a succinct answer. 0.94. What is the ratio of the Taxes (in $) in Mali in 2004 to that in 2006?
Offer a terse response. 0.84. What is the ratio of the Taxes (in $) in Uganda in 2004 to that in 2006?
Your answer should be very brief. 0.76. What is the ratio of the Taxes (in $) of Congo (Democratic) in 2004 to that in 2007?
Make the answer very short. 0.37. What is the ratio of the Taxes (in $) of France in 2004 to that in 2007?
Ensure brevity in your answer.  0.93. What is the ratio of the Taxes (in $) of Mali in 2004 to that in 2007?
Provide a succinct answer. 0.89. What is the ratio of the Taxes (in $) in Uganda in 2004 to that in 2007?
Your answer should be very brief. 0.65. What is the ratio of the Taxes (in $) in Congo (Democratic) in 2004 to that in 2008?
Provide a succinct answer. 0.23. What is the ratio of the Taxes (in $) of France in 2004 to that in 2008?
Your answer should be very brief. 0.93. What is the ratio of the Taxes (in $) in Mali in 2004 to that in 2008?
Your answer should be compact. 0.98. What is the ratio of the Taxes (in $) in Uganda in 2004 to that in 2008?
Make the answer very short. 0.53. What is the ratio of the Taxes (in $) of Congo (Democratic) in 2005 to that in 2006?
Make the answer very short. 0.73. What is the ratio of the Taxes (in $) in France in 2005 to that in 2006?
Give a very brief answer. 0.97. What is the ratio of the Taxes (in $) of Mali in 2005 to that in 2006?
Make the answer very short. 0.89. What is the ratio of the Taxes (in $) in Uganda in 2005 to that in 2006?
Provide a short and direct response. 0.85. What is the ratio of the Taxes (in $) of Congo (Democratic) in 2005 to that in 2007?
Give a very brief answer. 0.56. What is the ratio of the Taxes (in $) of France in 2005 to that in 2007?
Keep it short and to the point. 0.95. What is the ratio of the Taxes (in $) in Mali in 2005 to that in 2007?
Offer a very short reply. 0.93. What is the ratio of the Taxes (in $) of Uganda in 2005 to that in 2007?
Your response must be concise. 0.73. What is the ratio of the Taxes (in $) of Congo (Democratic) in 2005 to that in 2008?
Offer a terse response. 0.34. What is the ratio of the Taxes (in $) of France in 2005 to that in 2008?
Provide a succinct answer. 0.96. What is the ratio of the Taxes (in $) in Mali in 2005 to that in 2008?
Provide a short and direct response. 1.03. What is the ratio of the Taxes (in $) in Uganda in 2005 to that in 2008?
Offer a terse response. 0.6. What is the ratio of the Taxes (in $) in Congo (Democratic) in 2006 to that in 2007?
Your answer should be compact. 0.76. What is the ratio of the Taxes (in $) of Mali in 2006 to that in 2007?
Your response must be concise. 1.05. What is the ratio of the Taxes (in $) in Uganda in 2006 to that in 2007?
Your answer should be very brief. 0.86. What is the ratio of the Taxes (in $) in Congo (Democratic) in 2006 to that in 2008?
Offer a very short reply. 0.47. What is the ratio of the Taxes (in $) in France in 2006 to that in 2008?
Provide a short and direct response. 0.99. What is the ratio of the Taxes (in $) of Mali in 2006 to that in 2008?
Make the answer very short. 1.16. What is the ratio of the Taxes (in $) in Uganda in 2006 to that in 2008?
Make the answer very short. 0.7. What is the ratio of the Taxes (in $) of Congo (Democratic) in 2007 to that in 2008?
Your answer should be compact. 0.62. What is the ratio of the Taxes (in $) of Mali in 2007 to that in 2008?
Offer a very short reply. 1.11. What is the ratio of the Taxes (in $) of Uganda in 2007 to that in 2008?
Make the answer very short. 0.82. What is the difference between the highest and the second highest Taxes (in $) of Congo (Democratic)?
Keep it short and to the point. 1.20e+11. What is the difference between the highest and the second highest Taxes (in $) of France?
Offer a terse response. 2.90e+08. What is the difference between the highest and the second highest Taxes (in $) in Mali?
Your response must be concise. 1.26e+1. What is the difference between the highest and the second highest Taxes (in $) of Uganda?
Provide a short and direct response. 3.46e+11. What is the difference between the highest and the lowest Taxes (in $) in Congo (Democratic)?
Keep it short and to the point. 2.76e+11. What is the difference between the highest and the lowest Taxes (in $) of France?
Provide a succinct answer. 2.32e+1. What is the difference between the highest and the lowest Taxes (in $) in Mali?
Your response must be concise. 8.39e+1. What is the difference between the highest and the lowest Taxes (in $) in Uganda?
Your answer should be very brief. 1.35e+12. 